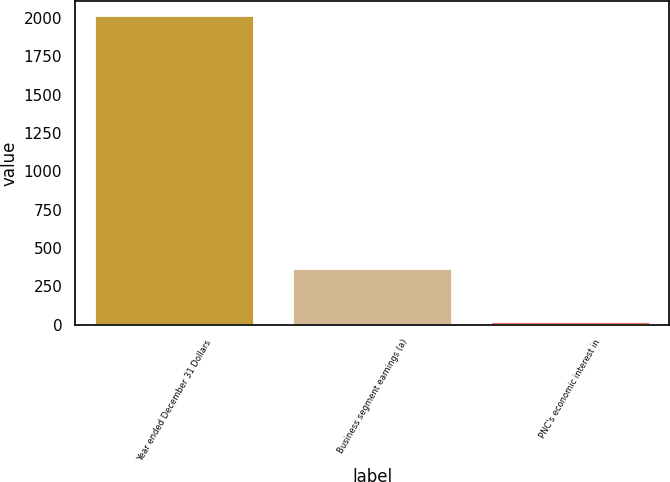Convert chart to OTSL. <chart><loc_0><loc_0><loc_500><loc_500><bar_chart><fcel>Year ended December 31 Dollars<fcel>Business segment earnings (a)<fcel>PNC's economic interest in<nl><fcel>2011<fcel>361<fcel>21<nl></chart> 